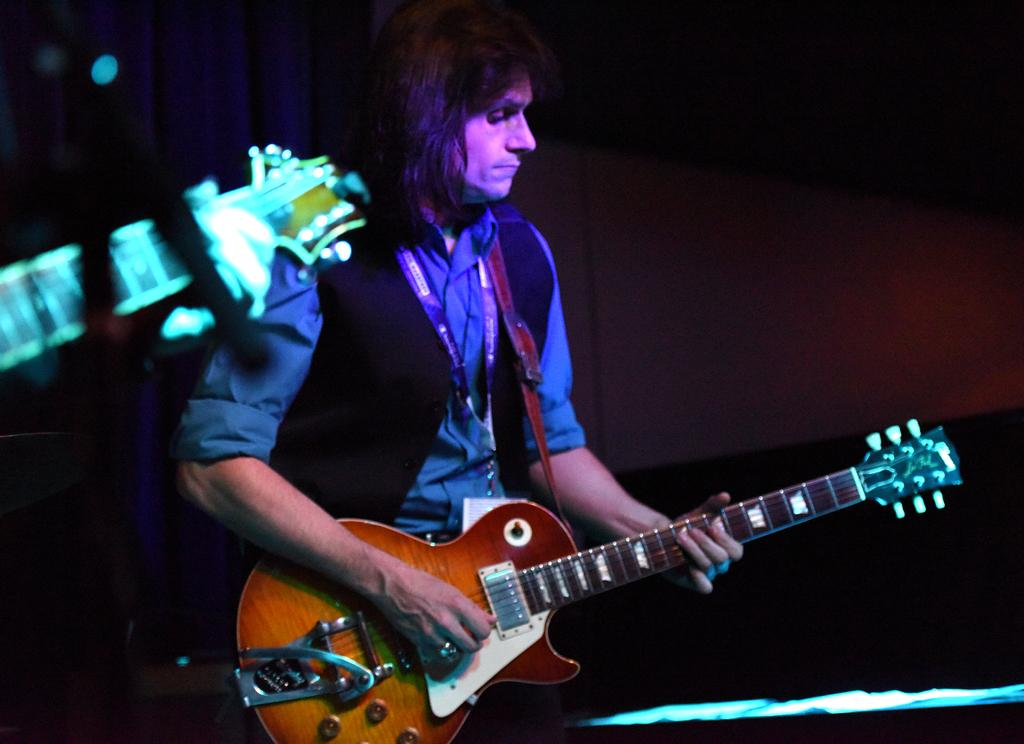What is the main subject of the image? The main subject of the image is a man. What is the man doing in the image? The man is standing in the image. What object is the man holding in the image? The man is holding a guitar in his hands. What type of pear is the man eating in the image? There is no pear present in the image; the man is holding a guitar. 